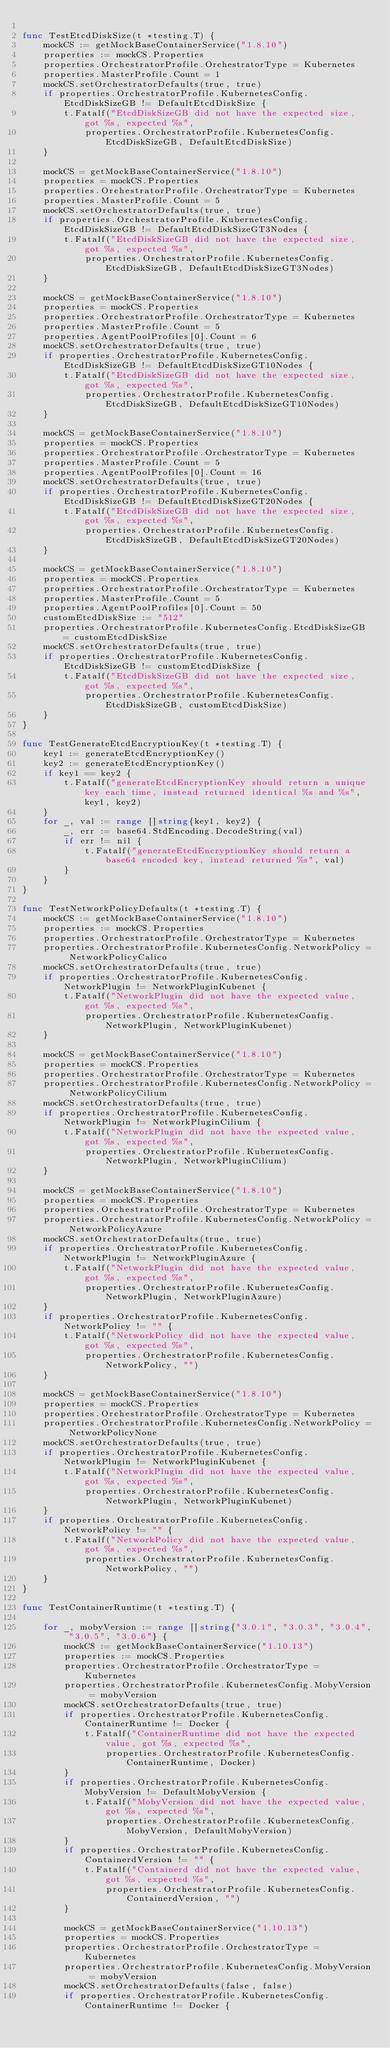Convert code to text. <code><loc_0><loc_0><loc_500><loc_500><_Go_>
func TestEtcdDiskSize(t *testing.T) {
	mockCS := getMockBaseContainerService("1.8.10")
	properties := mockCS.Properties
	properties.OrchestratorProfile.OrchestratorType = Kubernetes
	properties.MasterProfile.Count = 1
	mockCS.setOrchestratorDefaults(true, true)
	if properties.OrchestratorProfile.KubernetesConfig.EtcdDiskSizeGB != DefaultEtcdDiskSize {
		t.Fatalf("EtcdDiskSizeGB did not have the expected size, got %s, expected %s",
			properties.OrchestratorProfile.KubernetesConfig.EtcdDiskSizeGB, DefaultEtcdDiskSize)
	}

	mockCS = getMockBaseContainerService("1.8.10")
	properties = mockCS.Properties
	properties.OrchestratorProfile.OrchestratorType = Kubernetes
	properties.MasterProfile.Count = 5
	mockCS.setOrchestratorDefaults(true, true)
	if properties.OrchestratorProfile.KubernetesConfig.EtcdDiskSizeGB != DefaultEtcdDiskSizeGT3Nodes {
		t.Fatalf("EtcdDiskSizeGB did not have the expected size, got %s, expected %s",
			properties.OrchestratorProfile.KubernetesConfig.EtcdDiskSizeGB, DefaultEtcdDiskSizeGT3Nodes)
	}

	mockCS = getMockBaseContainerService("1.8.10")
	properties = mockCS.Properties
	properties.OrchestratorProfile.OrchestratorType = Kubernetes
	properties.MasterProfile.Count = 5
	properties.AgentPoolProfiles[0].Count = 6
	mockCS.setOrchestratorDefaults(true, true)
	if properties.OrchestratorProfile.KubernetesConfig.EtcdDiskSizeGB != DefaultEtcdDiskSizeGT10Nodes {
		t.Fatalf("EtcdDiskSizeGB did not have the expected size, got %s, expected %s",
			properties.OrchestratorProfile.KubernetesConfig.EtcdDiskSizeGB, DefaultEtcdDiskSizeGT10Nodes)
	}

	mockCS = getMockBaseContainerService("1.8.10")
	properties = mockCS.Properties
	properties.OrchestratorProfile.OrchestratorType = Kubernetes
	properties.MasterProfile.Count = 5
	properties.AgentPoolProfiles[0].Count = 16
	mockCS.setOrchestratorDefaults(true, true)
	if properties.OrchestratorProfile.KubernetesConfig.EtcdDiskSizeGB != DefaultEtcdDiskSizeGT20Nodes {
		t.Fatalf("EtcdDiskSizeGB did not have the expected size, got %s, expected %s",
			properties.OrchestratorProfile.KubernetesConfig.EtcdDiskSizeGB, DefaultEtcdDiskSizeGT20Nodes)
	}

	mockCS = getMockBaseContainerService("1.8.10")
	properties = mockCS.Properties
	properties.OrchestratorProfile.OrchestratorType = Kubernetes
	properties.MasterProfile.Count = 5
	properties.AgentPoolProfiles[0].Count = 50
	customEtcdDiskSize := "512"
	properties.OrchestratorProfile.KubernetesConfig.EtcdDiskSizeGB = customEtcdDiskSize
	mockCS.setOrchestratorDefaults(true, true)
	if properties.OrchestratorProfile.KubernetesConfig.EtcdDiskSizeGB != customEtcdDiskSize {
		t.Fatalf("EtcdDiskSizeGB did not have the expected size, got %s, expected %s",
			properties.OrchestratorProfile.KubernetesConfig.EtcdDiskSizeGB, customEtcdDiskSize)
	}
}

func TestGenerateEtcdEncryptionKey(t *testing.T) {
	key1 := generateEtcdEncryptionKey()
	key2 := generateEtcdEncryptionKey()
	if key1 == key2 {
		t.Fatalf("generateEtcdEncryptionKey should return a unique key each time, instead returned identical %s and %s", key1, key2)
	}
	for _, val := range []string{key1, key2} {
		_, err := base64.StdEncoding.DecodeString(val)
		if err != nil {
			t.Fatalf("generateEtcdEncryptionKey should return a base64 encoded key, instead returned %s", val)
		}
	}
}

func TestNetworkPolicyDefaults(t *testing.T) {
	mockCS := getMockBaseContainerService("1.8.10")
	properties := mockCS.Properties
	properties.OrchestratorProfile.OrchestratorType = Kubernetes
	properties.OrchestratorProfile.KubernetesConfig.NetworkPolicy = NetworkPolicyCalico
	mockCS.setOrchestratorDefaults(true, true)
	if properties.OrchestratorProfile.KubernetesConfig.NetworkPlugin != NetworkPluginKubenet {
		t.Fatalf("NetworkPlugin did not have the expected value, got %s, expected %s",
			properties.OrchestratorProfile.KubernetesConfig.NetworkPlugin, NetworkPluginKubenet)
	}

	mockCS = getMockBaseContainerService("1.8.10")
	properties = mockCS.Properties
	properties.OrchestratorProfile.OrchestratorType = Kubernetes
	properties.OrchestratorProfile.KubernetesConfig.NetworkPolicy = NetworkPolicyCilium
	mockCS.setOrchestratorDefaults(true, true)
	if properties.OrchestratorProfile.KubernetesConfig.NetworkPlugin != NetworkPluginCilium {
		t.Fatalf("NetworkPlugin did not have the expected value, got %s, expected %s",
			properties.OrchestratorProfile.KubernetesConfig.NetworkPlugin, NetworkPluginCilium)
	}

	mockCS = getMockBaseContainerService("1.8.10")
	properties = mockCS.Properties
	properties.OrchestratorProfile.OrchestratorType = Kubernetes
	properties.OrchestratorProfile.KubernetesConfig.NetworkPolicy = NetworkPolicyAzure
	mockCS.setOrchestratorDefaults(true, true)
	if properties.OrchestratorProfile.KubernetesConfig.NetworkPlugin != NetworkPluginAzure {
		t.Fatalf("NetworkPlugin did not have the expected value, got %s, expected %s",
			properties.OrchestratorProfile.KubernetesConfig.NetworkPlugin, NetworkPluginAzure)
	}
	if properties.OrchestratorProfile.KubernetesConfig.NetworkPolicy != "" {
		t.Fatalf("NetworkPolicy did not have the expected value, got %s, expected %s",
			properties.OrchestratorProfile.KubernetesConfig.NetworkPolicy, "")
	}

	mockCS = getMockBaseContainerService("1.8.10")
	properties = mockCS.Properties
	properties.OrchestratorProfile.OrchestratorType = Kubernetes
	properties.OrchestratorProfile.KubernetesConfig.NetworkPolicy = NetworkPolicyNone
	mockCS.setOrchestratorDefaults(true, true)
	if properties.OrchestratorProfile.KubernetesConfig.NetworkPlugin != NetworkPluginKubenet {
		t.Fatalf("NetworkPlugin did not have the expected value, got %s, expected %s",
			properties.OrchestratorProfile.KubernetesConfig.NetworkPlugin, NetworkPluginKubenet)
	}
	if properties.OrchestratorProfile.KubernetesConfig.NetworkPolicy != "" {
		t.Fatalf("NetworkPolicy did not have the expected value, got %s, expected %s",
			properties.OrchestratorProfile.KubernetesConfig.NetworkPolicy, "")
	}
}

func TestContainerRuntime(t *testing.T) {

	for _, mobyVersion := range []string{"3.0.1", "3.0.3", "3.0.4", "3.0.5", "3.0.6"} {
		mockCS := getMockBaseContainerService("1.10.13")
		properties := mockCS.Properties
		properties.OrchestratorProfile.OrchestratorType = Kubernetes
		properties.OrchestratorProfile.KubernetesConfig.MobyVersion = mobyVersion
		mockCS.setOrchestratorDefaults(true, true)
		if properties.OrchestratorProfile.KubernetesConfig.ContainerRuntime != Docker {
			t.Fatalf("ContainerRuntime did not have the expected value, got %s, expected %s",
				properties.OrchestratorProfile.KubernetesConfig.ContainerRuntime, Docker)
		}
		if properties.OrchestratorProfile.KubernetesConfig.MobyVersion != DefaultMobyVersion {
			t.Fatalf("MobyVersion did not have the expected value, got %s, expected %s",
				properties.OrchestratorProfile.KubernetesConfig.MobyVersion, DefaultMobyVersion)
		}
		if properties.OrchestratorProfile.KubernetesConfig.ContainerdVersion != "" {
			t.Fatalf("Containerd did not have the expected value, got %s, expected %s",
				properties.OrchestratorProfile.KubernetesConfig.ContainerdVersion, "")
		}

		mockCS = getMockBaseContainerService("1.10.13")
		properties = mockCS.Properties
		properties.OrchestratorProfile.OrchestratorType = Kubernetes
		properties.OrchestratorProfile.KubernetesConfig.MobyVersion = mobyVersion
		mockCS.setOrchestratorDefaults(false, false)
		if properties.OrchestratorProfile.KubernetesConfig.ContainerRuntime != Docker {</code> 